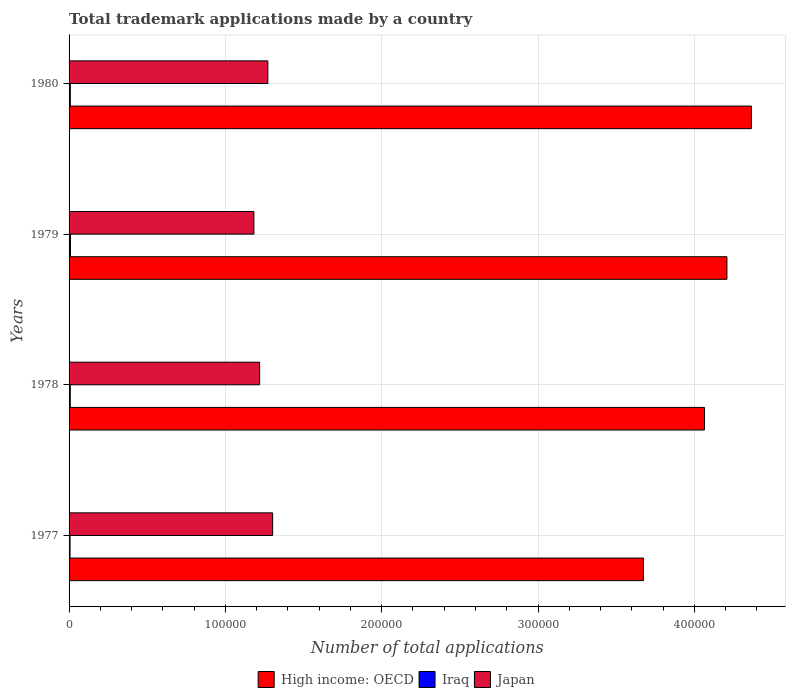How many different coloured bars are there?
Make the answer very short. 3. Are the number of bars per tick equal to the number of legend labels?
Offer a very short reply. Yes. Are the number of bars on each tick of the Y-axis equal?
Offer a very short reply. Yes. How many bars are there on the 3rd tick from the bottom?
Your response must be concise. 3. What is the label of the 2nd group of bars from the top?
Provide a short and direct response. 1979. In how many cases, is the number of bars for a given year not equal to the number of legend labels?
Provide a short and direct response. 0. What is the number of applications made by in High income: OECD in 1980?
Ensure brevity in your answer.  4.36e+05. Across all years, what is the maximum number of applications made by in Japan?
Offer a terse response. 1.30e+05. Across all years, what is the minimum number of applications made by in High income: OECD?
Provide a short and direct response. 3.67e+05. In which year was the number of applications made by in Iraq maximum?
Offer a very short reply. 1979. In which year was the number of applications made by in Japan minimum?
Your answer should be compact. 1979. What is the total number of applications made by in Iraq in the graph?
Ensure brevity in your answer.  3082. What is the difference between the number of applications made by in Iraq in 1978 and that in 1979?
Make the answer very short. -132. What is the difference between the number of applications made by in Japan in 1978 and the number of applications made by in High income: OECD in 1977?
Your response must be concise. -2.45e+05. What is the average number of applications made by in High income: OECD per year?
Ensure brevity in your answer.  4.08e+05. In the year 1978, what is the difference between the number of applications made by in High income: OECD and number of applications made by in Japan?
Your answer should be compact. 2.85e+05. In how many years, is the number of applications made by in Iraq greater than 380000 ?
Provide a short and direct response. 0. What is the ratio of the number of applications made by in High income: OECD in 1978 to that in 1979?
Your answer should be compact. 0.97. Is the number of applications made by in High income: OECD in 1977 less than that in 1978?
Your answer should be very brief. Yes. What is the difference between the highest and the second highest number of applications made by in Japan?
Make the answer very short. 3067. What is the difference between the highest and the lowest number of applications made by in Japan?
Offer a very short reply. 1.20e+04. What does the 2nd bar from the bottom in 1979 represents?
Offer a terse response. Iraq. Is it the case that in every year, the sum of the number of applications made by in Japan and number of applications made by in High income: OECD is greater than the number of applications made by in Iraq?
Offer a terse response. Yes. How many bars are there?
Your response must be concise. 12. What is the difference between two consecutive major ticks on the X-axis?
Make the answer very short. 1.00e+05. Does the graph contain any zero values?
Your answer should be very brief. No. How are the legend labels stacked?
Ensure brevity in your answer.  Horizontal. What is the title of the graph?
Your answer should be very brief. Total trademark applications made by a country. Does "Europe(developing only)" appear as one of the legend labels in the graph?
Your answer should be compact. No. What is the label or title of the X-axis?
Offer a terse response. Number of total applications. What is the label or title of the Y-axis?
Offer a very short reply. Years. What is the Number of total applications of High income: OECD in 1977?
Keep it short and to the point. 3.67e+05. What is the Number of total applications of Iraq in 1977?
Keep it short and to the point. 624. What is the Number of total applications in Japan in 1977?
Your answer should be compact. 1.30e+05. What is the Number of total applications in High income: OECD in 1978?
Offer a terse response. 4.06e+05. What is the Number of total applications of Iraq in 1978?
Your answer should be compact. 767. What is the Number of total applications in Japan in 1978?
Provide a short and direct response. 1.22e+05. What is the Number of total applications in High income: OECD in 1979?
Give a very brief answer. 4.21e+05. What is the Number of total applications in Iraq in 1979?
Offer a very short reply. 899. What is the Number of total applications of Japan in 1979?
Your response must be concise. 1.18e+05. What is the Number of total applications in High income: OECD in 1980?
Your answer should be very brief. 4.36e+05. What is the Number of total applications of Iraq in 1980?
Make the answer very short. 792. What is the Number of total applications of Japan in 1980?
Keep it short and to the point. 1.27e+05. Across all years, what is the maximum Number of total applications of High income: OECD?
Keep it short and to the point. 4.36e+05. Across all years, what is the maximum Number of total applications in Iraq?
Offer a terse response. 899. Across all years, what is the maximum Number of total applications in Japan?
Your answer should be compact. 1.30e+05. Across all years, what is the minimum Number of total applications of High income: OECD?
Ensure brevity in your answer.  3.67e+05. Across all years, what is the minimum Number of total applications in Iraq?
Keep it short and to the point. 624. Across all years, what is the minimum Number of total applications in Japan?
Keep it short and to the point. 1.18e+05. What is the total Number of total applications in High income: OECD in the graph?
Give a very brief answer. 1.63e+06. What is the total Number of total applications of Iraq in the graph?
Your answer should be very brief. 3082. What is the total Number of total applications of Japan in the graph?
Make the answer very short. 4.98e+05. What is the difference between the Number of total applications in High income: OECD in 1977 and that in 1978?
Give a very brief answer. -3.91e+04. What is the difference between the Number of total applications in Iraq in 1977 and that in 1978?
Provide a succinct answer. -143. What is the difference between the Number of total applications in Japan in 1977 and that in 1978?
Give a very brief answer. 8317. What is the difference between the Number of total applications of High income: OECD in 1977 and that in 1979?
Give a very brief answer. -5.34e+04. What is the difference between the Number of total applications of Iraq in 1977 and that in 1979?
Keep it short and to the point. -275. What is the difference between the Number of total applications in Japan in 1977 and that in 1979?
Give a very brief answer. 1.20e+04. What is the difference between the Number of total applications in High income: OECD in 1977 and that in 1980?
Your answer should be very brief. -6.91e+04. What is the difference between the Number of total applications of Iraq in 1977 and that in 1980?
Your answer should be compact. -168. What is the difference between the Number of total applications in Japan in 1977 and that in 1980?
Give a very brief answer. 3067. What is the difference between the Number of total applications in High income: OECD in 1978 and that in 1979?
Offer a very short reply. -1.44e+04. What is the difference between the Number of total applications in Iraq in 1978 and that in 1979?
Give a very brief answer. -132. What is the difference between the Number of total applications of Japan in 1978 and that in 1979?
Offer a terse response. 3666. What is the difference between the Number of total applications in High income: OECD in 1978 and that in 1980?
Offer a terse response. -3.00e+04. What is the difference between the Number of total applications of Japan in 1978 and that in 1980?
Ensure brevity in your answer.  -5250. What is the difference between the Number of total applications in High income: OECD in 1979 and that in 1980?
Your answer should be very brief. -1.56e+04. What is the difference between the Number of total applications in Iraq in 1979 and that in 1980?
Your answer should be very brief. 107. What is the difference between the Number of total applications in Japan in 1979 and that in 1980?
Give a very brief answer. -8916. What is the difference between the Number of total applications in High income: OECD in 1977 and the Number of total applications in Iraq in 1978?
Ensure brevity in your answer.  3.67e+05. What is the difference between the Number of total applications of High income: OECD in 1977 and the Number of total applications of Japan in 1978?
Offer a very short reply. 2.45e+05. What is the difference between the Number of total applications of Iraq in 1977 and the Number of total applications of Japan in 1978?
Provide a succinct answer. -1.21e+05. What is the difference between the Number of total applications in High income: OECD in 1977 and the Number of total applications in Iraq in 1979?
Offer a very short reply. 3.66e+05. What is the difference between the Number of total applications in High income: OECD in 1977 and the Number of total applications in Japan in 1979?
Provide a succinct answer. 2.49e+05. What is the difference between the Number of total applications of Iraq in 1977 and the Number of total applications of Japan in 1979?
Your answer should be compact. -1.18e+05. What is the difference between the Number of total applications in High income: OECD in 1977 and the Number of total applications in Iraq in 1980?
Offer a very short reply. 3.67e+05. What is the difference between the Number of total applications of High income: OECD in 1977 and the Number of total applications of Japan in 1980?
Provide a succinct answer. 2.40e+05. What is the difference between the Number of total applications of Iraq in 1977 and the Number of total applications of Japan in 1980?
Provide a short and direct response. -1.27e+05. What is the difference between the Number of total applications of High income: OECD in 1978 and the Number of total applications of Iraq in 1979?
Your answer should be compact. 4.06e+05. What is the difference between the Number of total applications of High income: OECD in 1978 and the Number of total applications of Japan in 1979?
Ensure brevity in your answer.  2.88e+05. What is the difference between the Number of total applications of Iraq in 1978 and the Number of total applications of Japan in 1979?
Make the answer very short. -1.17e+05. What is the difference between the Number of total applications in High income: OECD in 1978 and the Number of total applications in Iraq in 1980?
Make the answer very short. 4.06e+05. What is the difference between the Number of total applications of High income: OECD in 1978 and the Number of total applications of Japan in 1980?
Provide a succinct answer. 2.79e+05. What is the difference between the Number of total applications of Iraq in 1978 and the Number of total applications of Japan in 1980?
Make the answer very short. -1.26e+05. What is the difference between the Number of total applications of High income: OECD in 1979 and the Number of total applications of Iraq in 1980?
Your response must be concise. 4.20e+05. What is the difference between the Number of total applications of High income: OECD in 1979 and the Number of total applications of Japan in 1980?
Your answer should be very brief. 2.94e+05. What is the difference between the Number of total applications in Iraq in 1979 and the Number of total applications in Japan in 1980?
Provide a short and direct response. -1.26e+05. What is the average Number of total applications in High income: OECD per year?
Your answer should be compact. 4.08e+05. What is the average Number of total applications in Iraq per year?
Offer a terse response. 770.5. What is the average Number of total applications of Japan per year?
Your answer should be very brief. 1.24e+05. In the year 1977, what is the difference between the Number of total applications of High income: OECD and Number of total applications of Iraq?
Give a very brief answer. 3.67e+05. In the year 1977, what is the difference between the Number of total applications of High income: OECD and Number of total applications of Japan?
Provide a succinct answer. 2.37e+05. In the year 1977, what is the difference between the Number of total applications of Iraq and Number of total applications of Japan?
Your answer should be very brief. -1.30e+05. In the year 1978, what is the difference between the Number of total applications in High income: OECD and Number of total applications in Iraq?
Offer a very short reply. 4.06e+05. In the year 1978, what is the difference between the Number of total applications in High income: OECD and Number of total applications in Japan?
Provide a succinct answer. 2.85e+05. In the year 1978, what is the difference between the Number of total applications of Iraq and Number of total applications of Japan?
Provide a succinct answer. -1.21e+05. In the year 1979, what is the difference between the Number of total applications in High income: OECD and Number of total applications in Iraq?
Your answer should be very brief. 4.20e+05. In the year 1979, what is the difference between the Number of total applications in High income: OECD and Number of total applications in Japan?
Ensure brevity in your answer.  3.03e+05. In the year 1979, what is the difference between the Number of total applications of Iraq and Number of total applications of Japan?
Make the answer very short. -1.17e+05. In the year 1980, what is the difference between the Number of total applications of High income: OECD and Number of total applications of Iraq?
Offer a terse response. 4.36e+05. In the year 1980, what is the difference between the Number of total applications in High income: OECD and Number of total applications in Japan?
Offer a very short reply. 3.09e+05. In the year 1980, what is the difference between the Number of total applications in Iraq and Number of total applications in Japan?
Give a very brief answer. -1.26e+05. What is the ratio of the Number of total applications in High income: OECD in 1977 to that in 1978?
Offer a very short reply. 0.9. What is the ratio of the Number of total applications of Iraq in 1977 to that in 1978?
Your answer should be compact. 0.81. What is the ratio of the Number of total applications of Japan in 1977 to that in 1978?
Provide a short and direct response. 1.07. What is the ratio of the Number of total applications of High income: OECD in 1977 to that in 1979?
Offer a terse response. 0.87. What is the ratio of the Number of total applications in Iraq in 1977 to that in 1979?
Ensure brevity in your answer.  0.69. What is the ratio of the Number of total applications in Japan in 1977 to that in 1979?
Your response must be concise. 1.1. What is the ratio of the Number of total applications in High income: OECD in 1977 to that in 1980?
Your response must be concise. 0.84. What is the ratio of the Number of total applications of Iraq in 1977 to that in 1980?
Offer a very short reply. 0.79. What is the ratio of the Number of total applications in Japan in 1977 to that in 1980?
Provide a succinct answer. 1.02. What is the ratio of the Number of total applications of High income: OECD in 1978 to that in 1979?
Offer a very short reply. 0.97. What is the ratio of the Number of total applications in Iraq in 1978 to that in 1979?
Provide a short and direct response. 0.85. What is the ratio of the Number of total applications of Japan in 1978 to that in 1979?
Provide a short and direct response. 1.03. What is the ratio of the Number of total applications in High income: OECD in 1978 to that in 1980?
Keep it short and to the point. 0.93. What is the ratio of the Number of total applications in Iraq in 1978 to that in 1980?
Give a very brief answer. 0.97. What is the ratio of the Number of total applications of Japan in 1978 to that in 1980?
Offer a terse response. 0.96. What is the ratio of the Number of total applications in High income: OECD in 1979 to that in 1980?
Give a very brief answer. 0.96. What is the ratio of the Number of total applications of Iraq in 1979 to that in 1980?
Offer a terse response. 1.14. What is the ratio of the Number of total applications of Japan in 1979 to that in 1980?
Provide a succinct answer. 0.93. What is the difference between the highest and the second highest Number of total applications in High income: OECD?
Ensure brevity in your answer.  1.56e+04. What is the difference between the highest and the second highest Number of total applications in Iraq?
Your response must be concise. 107. What is the difference between the highest and the second highest Number of total applications in Japan?
Make the answer very short. 3067. What is the difference between the highest and the lowest Number of total applications of High income: OECD?
Your answer should be compact. 6.91e+04. What is the difference between the highest and the lowest Number of total applications in Iraq?
Provide a short and direct response. 275. What is the difference between the highest and the lowest Number of total applications of Japan?
Make the answer very short. 1.20e+04. 